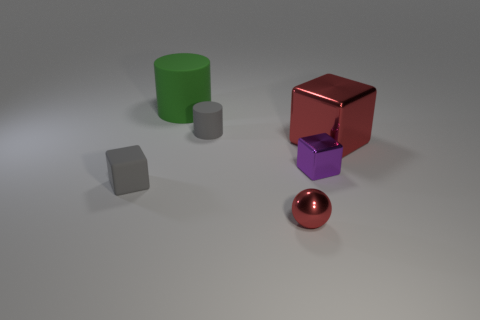Subtract all red cubes. How many cubes are left? 2 Add 1 large brown metal blocks. How many objects exist? 7 Subtract 1 purple blocks. How many objects are left? 5 Subtract all cylinders. How many objects are left? 4 Subtract all yellow rubber blocks. Subtract all small red objects. How many objects are left? 5 Add 1 gray rubber cylinders. How many gray rubber cylinders are left? 2 Add 5 tiny gray things. How many tiny gray things exist? 7 